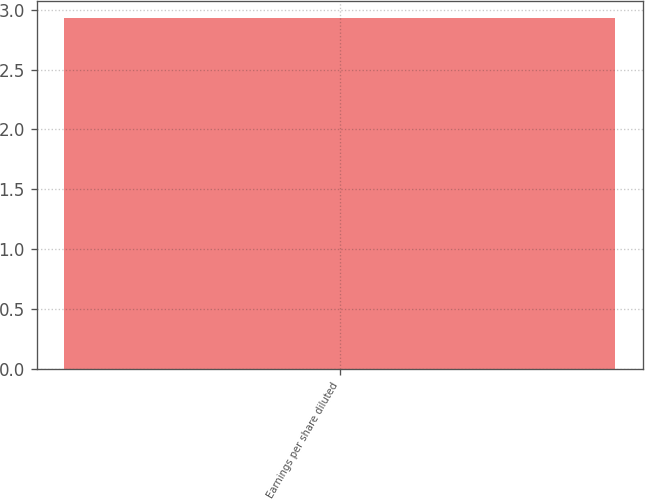Convert chart to OTSL. <chart><loc_0><loc_0><loc_500><loc_500><bar_chart><fcel>Earnings per share diluted<nl><fcel>2.93<nl></chart> 